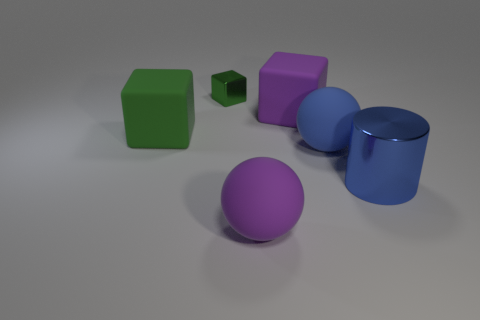There is a large thing that is the same color as the cylinder; what is it made of?
Offer a terse response. Rubber. What is the color of the rubber thing that is in front of the large metallic cylinder?
Offer a very short reply. Purple. How many other things are there of the same material as the big green thing?
Your response must be concise. 3. Is the number of metallic cubes that are behind the purple sphere greater than the number of big purple spheres right of the cylinder?
Your answer should be compact. Yes. How many large things are to the right of the large blue matte ball?
Keep it short and to the point. 1. Is the tiny block made of the same material as the cube right of the green metallic thing?
Offer a terse response. No. Is there anything else that is the same shape as the big blue metallic thing?
Provide a succinct answer. No. Do the cylinder and the small cube have the same material?
Your response must be concise. Yes. Is there a matte object to the left of the blue thing behind the large metal cylinder?
Your answer should be very brief. Yes. How many things are both in front of the purple matte cube and on the right side of the green shiny cube?
Ensure brevity in your answer.  3. 